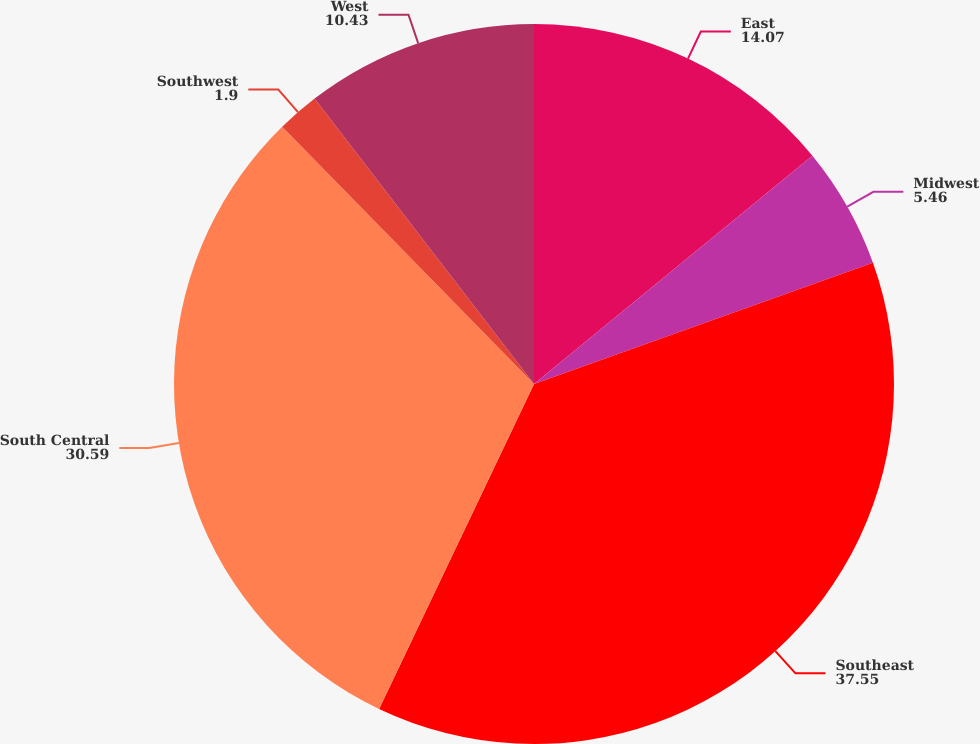Convert chart. <chart><loc_0><loc_0><loc_500><loc_500><pie_chart><fcel>East<fcel>Midwest<fcel>Southeast<fcel>South Central<fcel>Southwest<fcel>West<nl><fcel>14.07%<fcel>5.46%<fcel>37.55%<fcel>30.59%<fcel>1.9%<fcel>10.43%<nl></chart> 